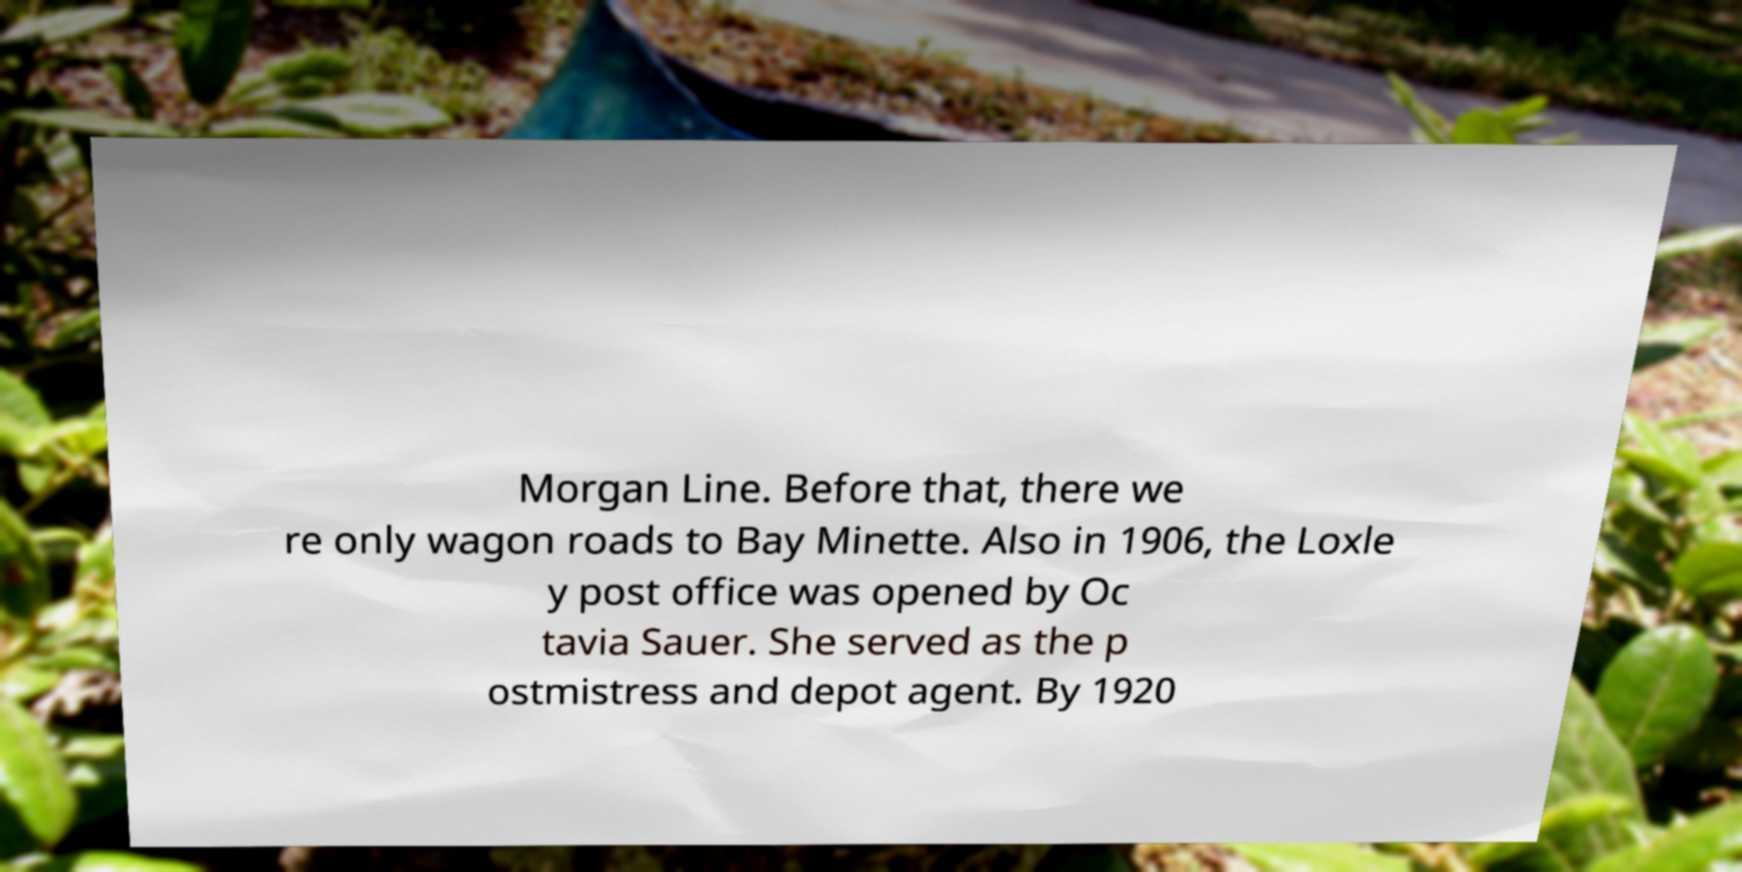Can you read and provide the text displayed in the image?This photo seems to have some interesting text. Can you extract and type it out for me? Morgan Line. Before that, there we re only wagon roads to Bay Minette. Also in 1906, the Loxle y post office was opened by Oc tavia Sauer. She served as the p ostmistress and depot agent. By 1920 